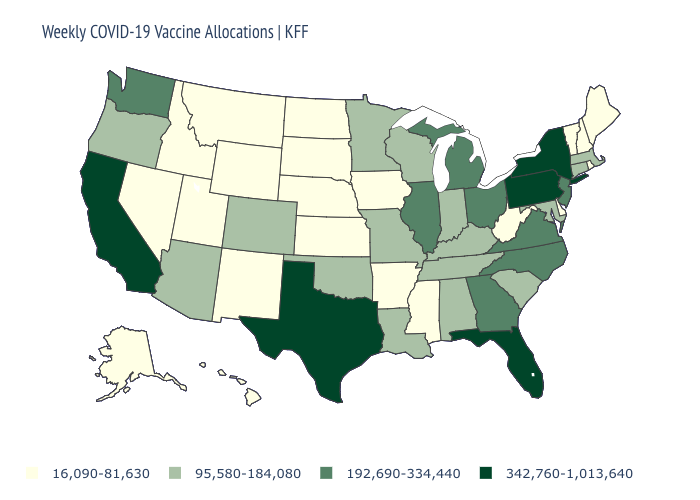Name the states that have a value in the range 342,760-1,013,640?
Concise answer only. California, Florida, New York, Pennsylvania, Texas. How many symbols are there in the legend?
Keep it brief. 4. Does South Dakota have the lowest value in the USA?
Short answer required. Yes. What is the value of Texas?
Short answer required. 342,760-1,013,640. Does New Hampshire have the same value as Texas?
Write a very short answer. No. What is the value of Arkansas?
Keep it brief. 16,090-81,630. Which states have the lowest value in the USA?
Concise answer only. Alaska, Arkansas, Delaware, Hawaii, Idaho, Iowa, Kansas, Maine, Mississippi, Montana, Nebraska, Nevada, New Hampshire, New Mexico, North Dakota, Rhode Island, South Dakota, Utah, Vermont, West Virginia, Wyoming. Among the states that border North Carolina , which have the lowest value?
Give a very brief answer. South Carolina, Tennessee. Name the states that have a value in the range 16,090-81,630?
Short answer required. Alaska, Arkansas, Delaware, Hawaii, Idaho, Iowa, Kansas, Maine, Mississippi, Montana, Nebraska, Nevada, New Hampshire, New Mexico, North Dakota, Rhode Island, South Dakota, Utah, Vermont, West Virginia, Wyoming. Among the states that border New York , does Vermont have the lowest value?
Short answer required. Yes. What is the lowest value in states that border Rhode Island?
Answer briefly. 95,580-184,080. What is the value of Massachusetts?
Short answer required. 95,580-184,080. Does Illinois have the lowest value in the MidWest?
Short answer required. No. Which states have the lowest value in the USA?
Keep it brief. Alaska, Arkansas, Delaware, Hawaii, Idaho, Iowa, Kansas, Maine, Mississippi, Montana, Nebraska, Nevada, New Hampshire, New Mexico, North Dakota, Rhode Island, South Dakota, Utah, Vermont, West Virginia, Wyoming. Name the states that have a value in the range 95,580-184,080?
Write a very short answer. Alabama, Arizona, Colorado, Connecticut, Indiana, Kentucky, Louisiana, Maryland, Massachusetts, Minnesota, Missouri, Oklahoma, Oregon, South Carolina, Tennessee, Wisconsin. 